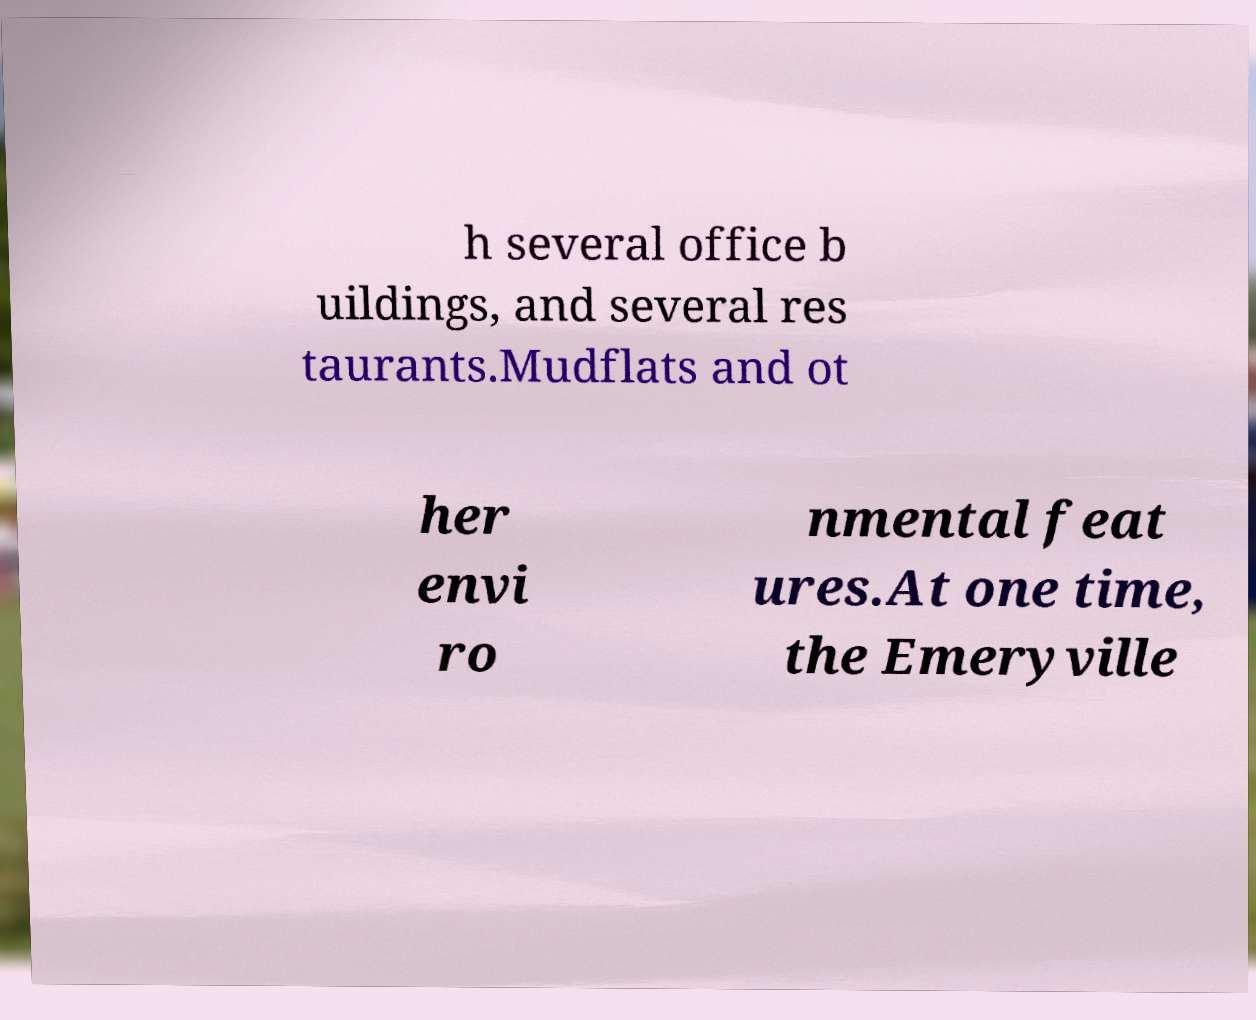Could you extract and type out the text from this image? h several office b uildings, and several res taurants.Mudflats and ot her envi ro nmental feat ures.At one time, the Emeryville 